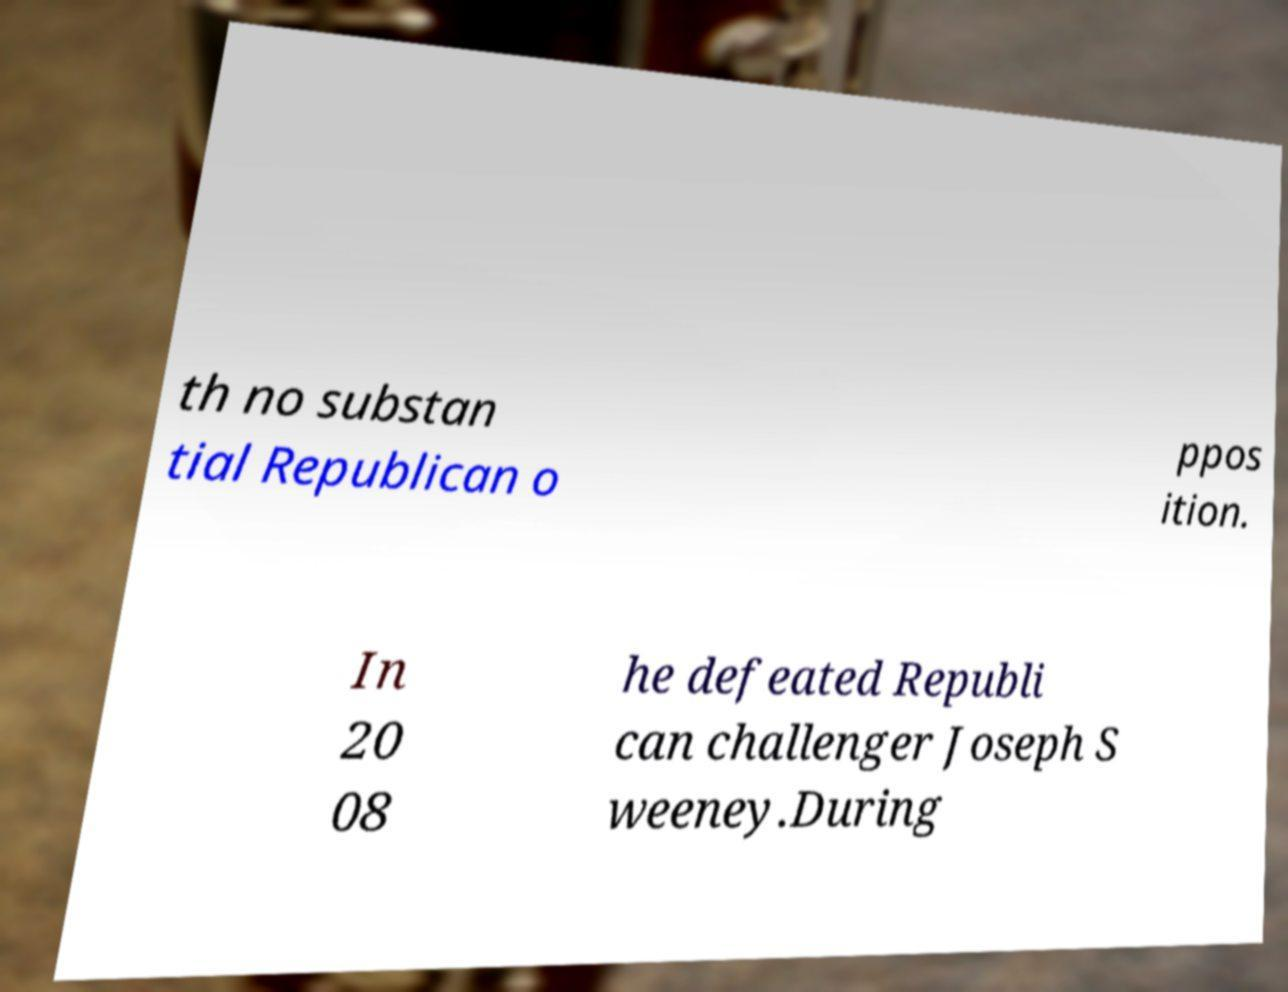There's text embedded in this image that I need extracted. Can you transcribe it verbatim? th no substan tial Republican o ppos ition. In 20 08 he defeated Republi can challenger Joseph S weeney.During 